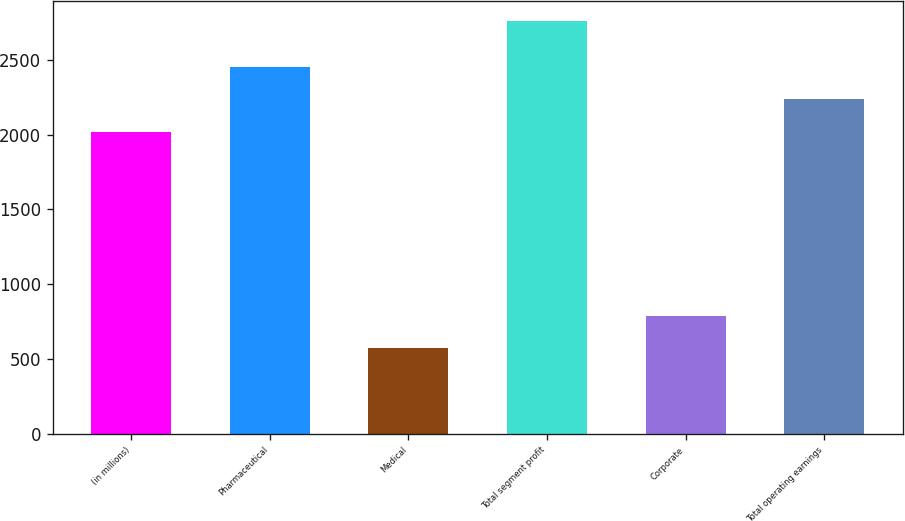Convert chart. <chart><loc_0><loc_0><loc_500><loc_500><bar_chart><fcel>(in millions)<fcel>Pharmaceutical<fcel>Medical<fcel>Total segment profit<fcel>Corporate<fcel>Total operating earnings<nl><fcel>2017<fcel>2454.4<fcel>572<fcel>2759<fcel>790.7<fcel>2235.7<nl></chart> 